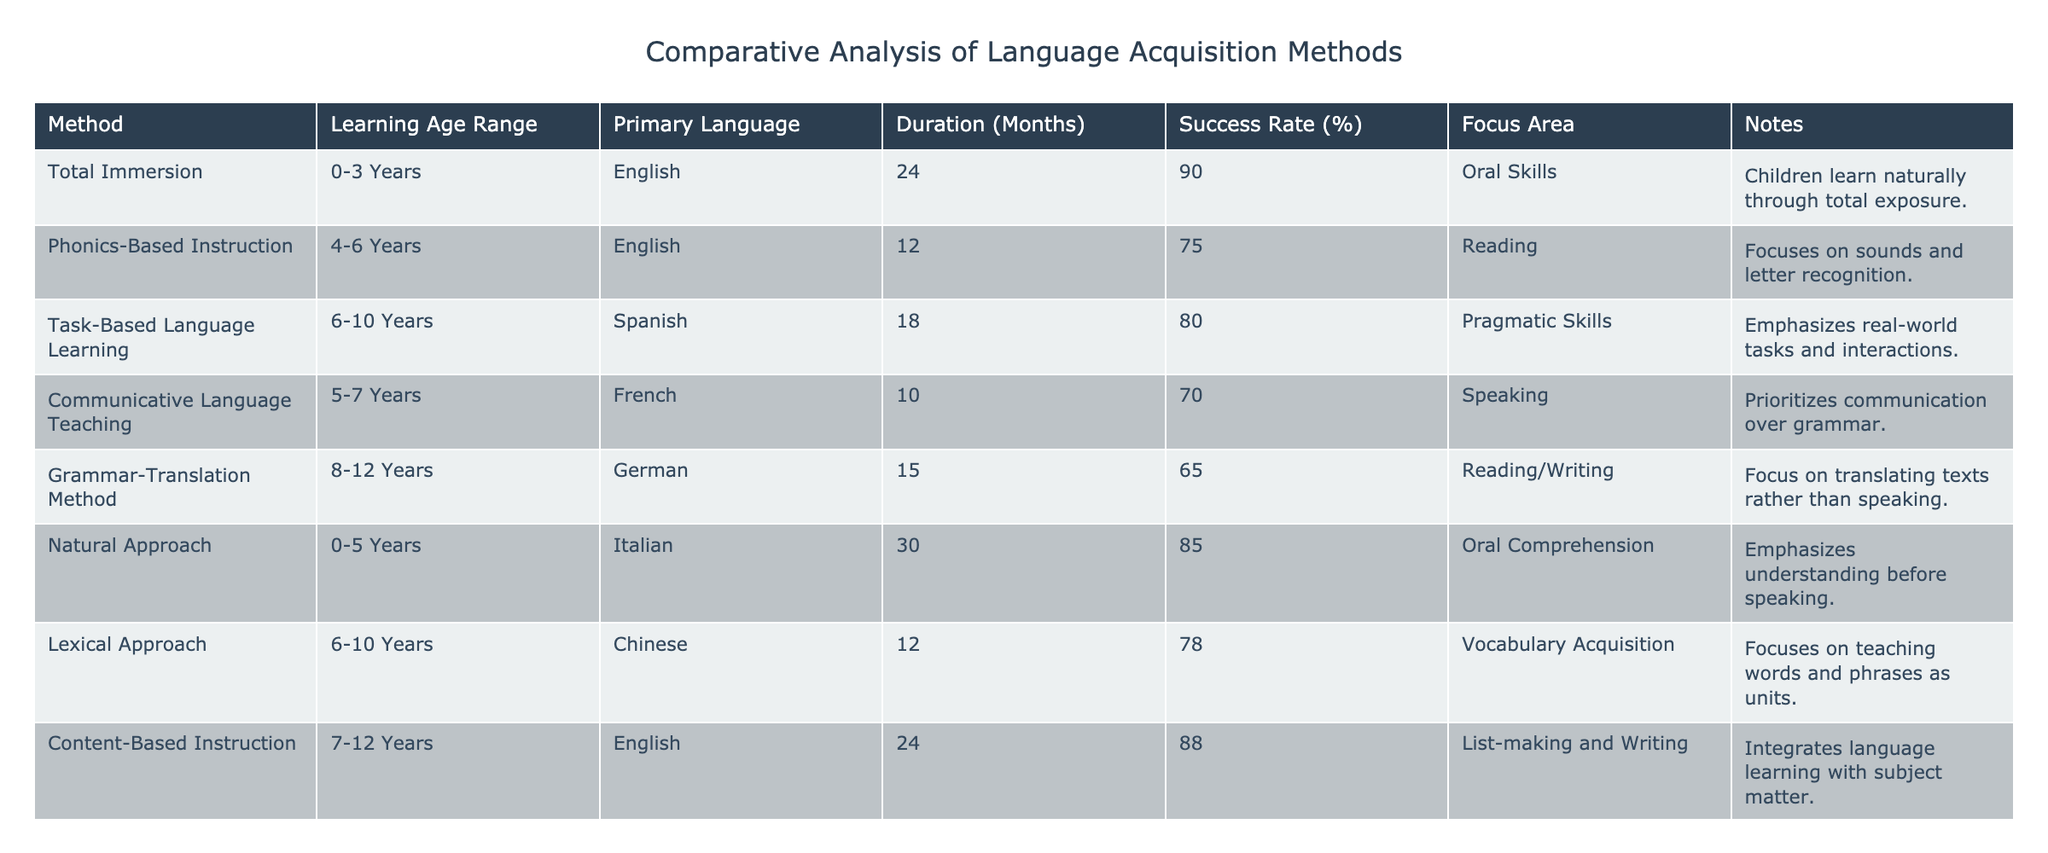What is the success rate of the Total Immersion method? The success rate is listed directly in the table under the Total Immersion method, showing a percentage value of 90.
Answer: 90% Which language acquisition method focuses primarily on vocabulary acquisition? By checking the table, the Lexical Approach is specifically marked as focusing on vocabulary acquisition.
Answer: Lexical Approach What is the average duration of language acquisition methods that have a success rate of 80% or above? To find the average, identify methods with success rates of 80% or higher: Total Immersion (24 months), Natural Approach (30 months), Task-Based Language Learning (18 months), and Content-Based Instruction (24 months). The total duration is 24 + 30 + 18 + 24 = 96 months. The average is 96/4 = 24 months.
Answer: 24 months Does the Natural Approach method have a higher success rate than the Grammar-Translation Method? When comparing the two methods, the Natural Approach has a success rate of 85%, while the Grammar-Translation Method has a success rate of 65%. Since 85% is greater than 65%, the statement is true.
Answer: Yes Which method offers the shortest duration with the highest success rate among those listed? The methods with the highest success rates are Total Immersion (24 months, 90%), Content-Based Instruction (24 months, 88%), and Natural Approach (30 months, 85%). Total Immersion and Content-Based Instruction are both 24 months long and have the highest rates of 90% and 88%. Therefore, 24 months is the shortest duration with the highest success rates.
Answer: 24 months 